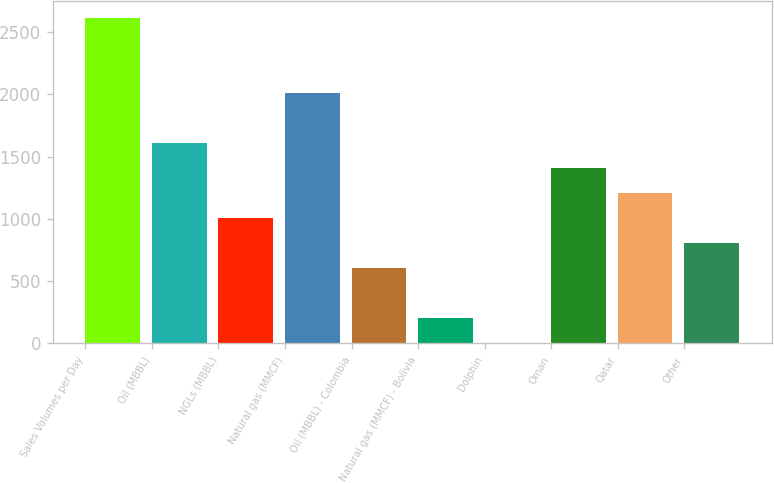<chart> <loc_0><loc_0><loc_500><loc_500><bar_chart><fcel>Sales Volumes per Day<fcel>Oil (MBBL)<fcel>NGLs (MBBL)<fcel>Natural gas (MMCF)<fcel>Oil (MBBL) - Colombia<fcel>Natural gas (MMCF) - Bolivia<fcel>Dolphin<fcel>Oman<fcel>Qatar<fcel>Other<nl><fcel>2615.1<fcel>1611.6<fcel>1009.5<fcel>2013<fcel>608.1<fcel>206.7<fcel>6<fcel>1410.9<fcel>1210.2<fcel>808.8<nl></chart> 